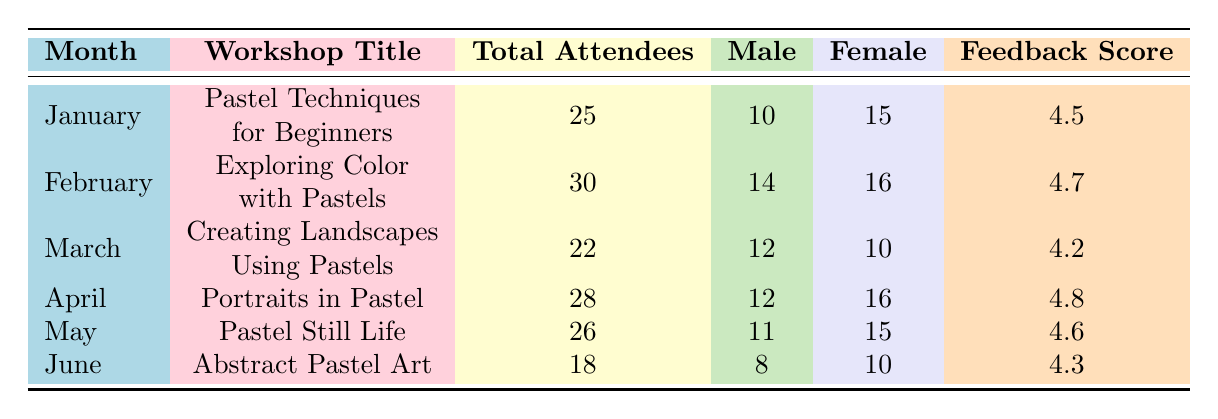What was the total number of attendees for the workshop "Creating Landscapes Using Pastels"? The table indicates that the total attendees for "Creating Landscapes Using Pastels" in March was 22.
Answer: 22 Which month had the highest feedback score? By examining the Feedback Score column, April had the highest score of 4.8.
Answer: April How many more females than males attended the workshop in February? In February, the male attendees were 14 and female attendees were 16, so the difference is 16 - 14 = 2 more females.
Answer: 2 What is the average feedback score for all workshops? To find the average, we sum the feedback scores (4.5 + 4.7 + 4.2 + 4.8 + 4.6 + 4.3 = 27.1) and divide by the number of workshops (6), yielding an average of 27.1 / 6 = 4.52.
Answer: 4.52 Did any workshop have a total attendance of less than 20? Upon review, the lowest total attendance listed is 18 in June for "Abstract Pastel Art," indicating that yes, there was a workshop with less than 20 attendees.
Answer: Yes What is the total number of attendees across all months? By adding the total attendees: 25 + 30 + 22 + 28 + 26 + 18 = 179, we determine the total attendees across all months.
Answer: 179 In which month were the male attendees the least? Looking at the Male column, June shows the lowest value of 8.
Answer: June How many attendees were there in the workshop "Pastel Still Life"? The table lists the total attendees for "Pastel Still Life" in May as 26.
Answer: 26 Which month had the smallest difference between male and female attendees? The differences for each month are: January (5), February (2), March (2), April (4), May (4), June (2). The smallest differences are in February, March, and June with a difference of 2.
Answer: February, March, and June What workshop had the greatest female participation relative to males? Comparing the ratios, April had 16 females and 12 males, leading to a ratio (16:12) = 4:3. This is the highest ratio among all months, indicating the greatest female participation.
Answer: Portraits in Pastel 